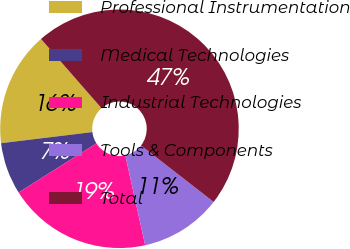<chart> <loc_0><loc_0><loc_500><loc_500><pie_chart><fcel>Professional Instrumentation<fcel>Medical Technologies<fcel>Industrial Technologies<fcel>Tools & Components<fcel>Total<nl><fcel>15.5%<fcel>7.04%<fcel>19.49%<fcel>11.03%<fcel>46.93%<nl></chart> 